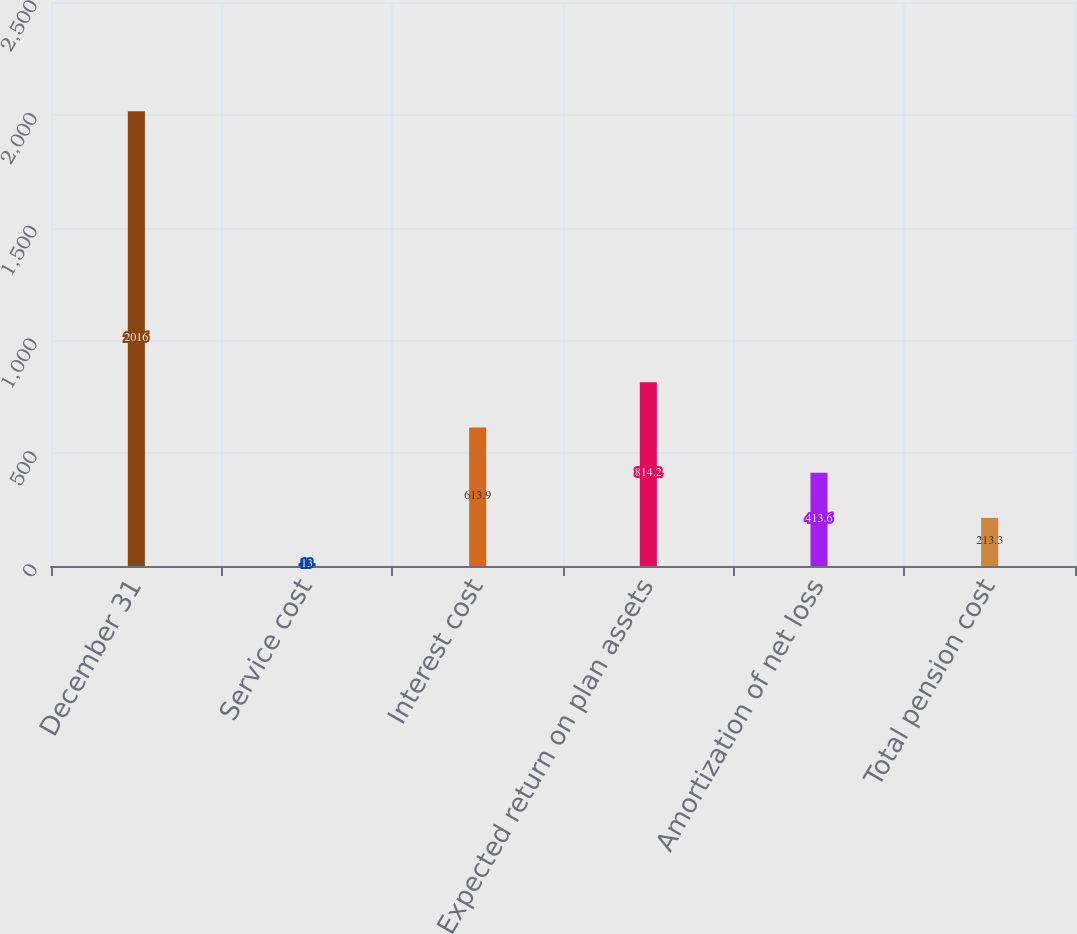<chart> <loc_0><loc_0><loc_500><loc_500><bar_chart><fcel>December 31<fcel>Service cost<fcel>Interest cost<fcel>Expected return on plan assets<fcel>Amortization of net loss<fcel>Total pension cost<nl><fcel>2016<fcel>13<fcel>613.9<fcel>814.2<fcel>413.6<fcel>213.3<nl></chart> 